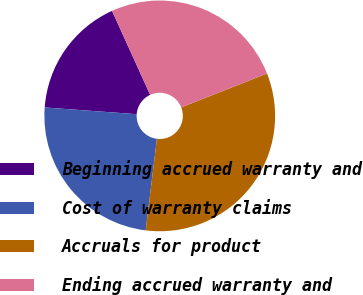<chart> <loc_0><loc_0><loc_500><loc_500><pie_chart><fcel>Beginning accrued warranty and<fcel>Cost of warranty claims<fcel>Accruals for product<fcel>Ending accrued warranty and<nl><fcel>17.05%<fcel>24.22%<fcel>32.93%<fcel>25.8%<nl></chart> 